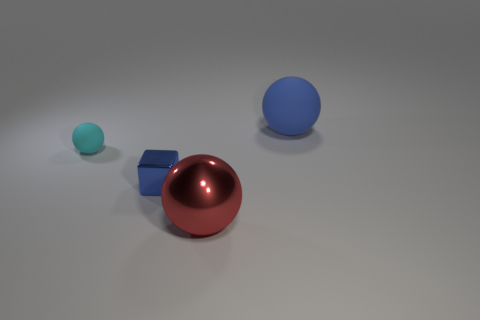How would you describe the lighting and the setting where these objects are placed? The objects are placed in a simple 3D-rendered setting with a plain, light gray background. The lighting is soft and diffused, coming from above, creating subtle shadows directly underneath the objects which suggests a gentle overhead light source. 